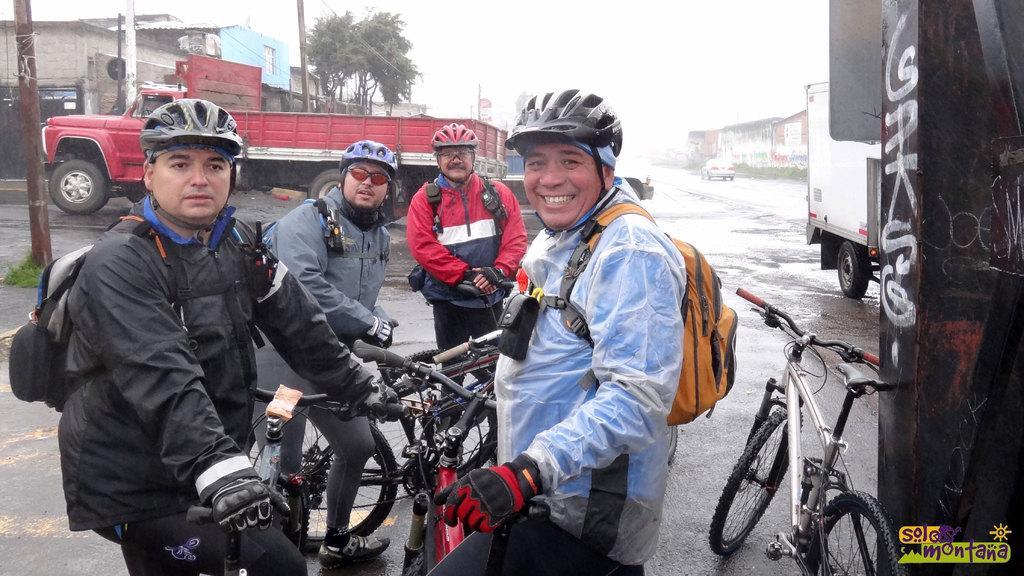Please provide a concise description of this image. In this image I can see group of people standing and I can also see few bicycles. In front the person is wearing blue color shirt and wearing an orange color bag, background I can see few vehicles, trees in green color. I can also see few buildings, poles and the sky is in white color. 